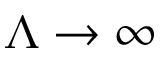Convert formula to latex. <formula><loc_0><loc_0><loc_500><loc_500>\Lambda \to \infty</formula> 